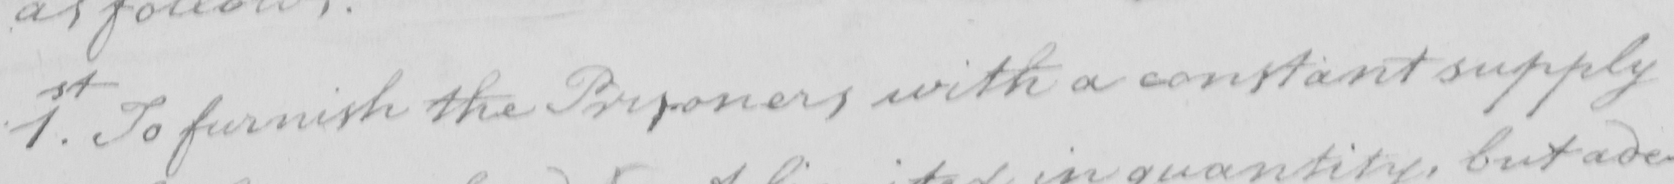What does this handwritten line say? 1.st To furnish the Prisoners with a constant supply 